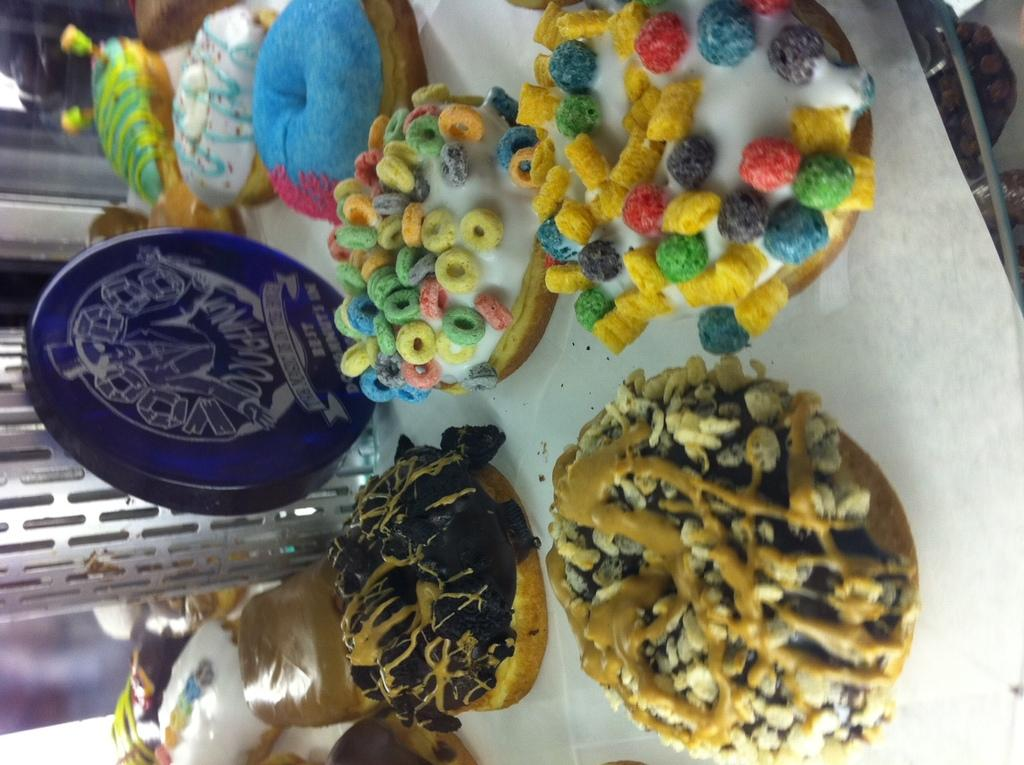What types of items can be seen in the image? There are food items in the image. How can the food items be distinguished from one another? The food items have different colors. What is the color of the object that is not a food item? There is a blue color object in the image. What is the color of the surface on which the food items and blue object are placed? The food items and blue object are on a white color surface. How does the amusement park affect the digestion of the food items in the image? There is no amusement park or mention of digestion in the image; it only features food items and a blue object on a white surface. 